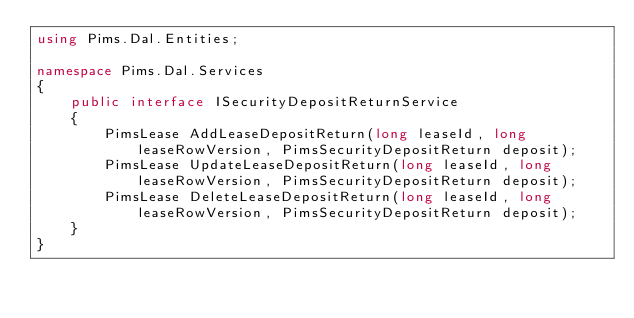Convert code to text. <code><loc_0><loc_0><loc_500><loc_500><_C#_>using Pims.Dal.Entities;

namespace Pims.Dal.Services
{
    public interface ISecurityDepositReturnService
    {
        PimsLease AddLeaseDepositReturn(long leaseId, long leaseRowVersion, PimsSecurityDepositReturn deposit);
        PimsLease UpdateLeaseDepositReturn(long leaseId, long leaseRowVersion, PimsSecurityDepositReturn deposit);
        PimsLease DeleteLeaseDepositReturn(long leaseId, long leaseRowVersion, PimsSecurityDepositReturn deposit);
    }
}
</code> 